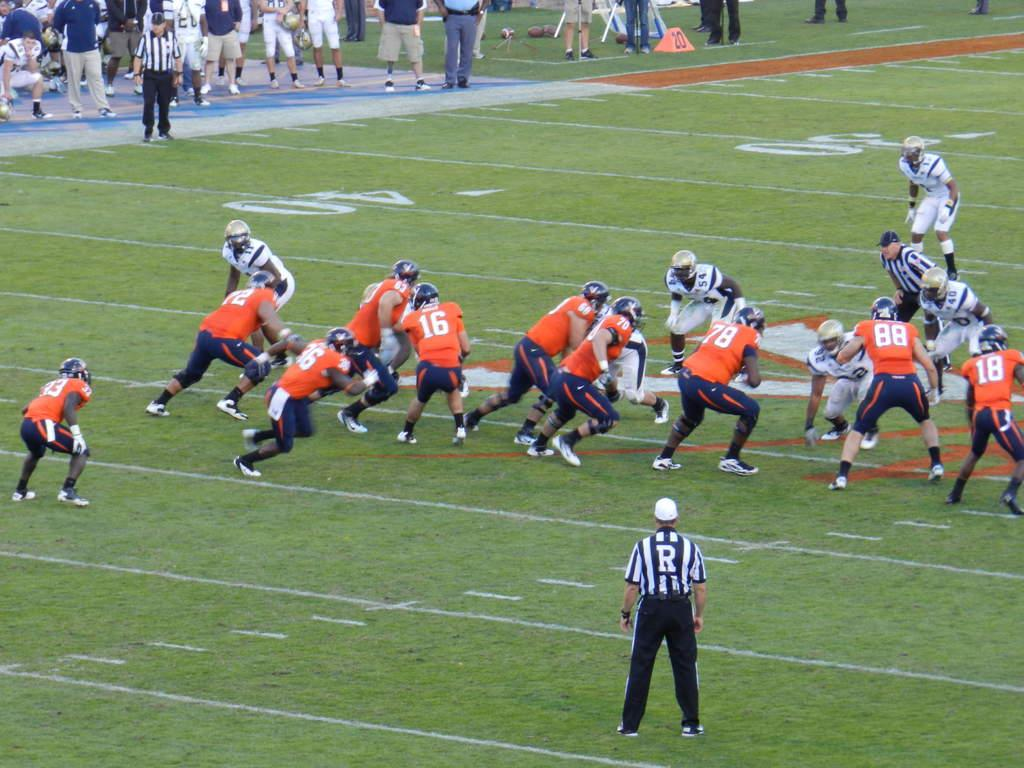What activity is taking place in the image? There are people playing at a ground in the image. What are the people who are not playing doing? Some people are standing and watching the game. How does the stranger participate in the game in the image? There is no stranger present in the image; it only shows people playing and watching the game. 